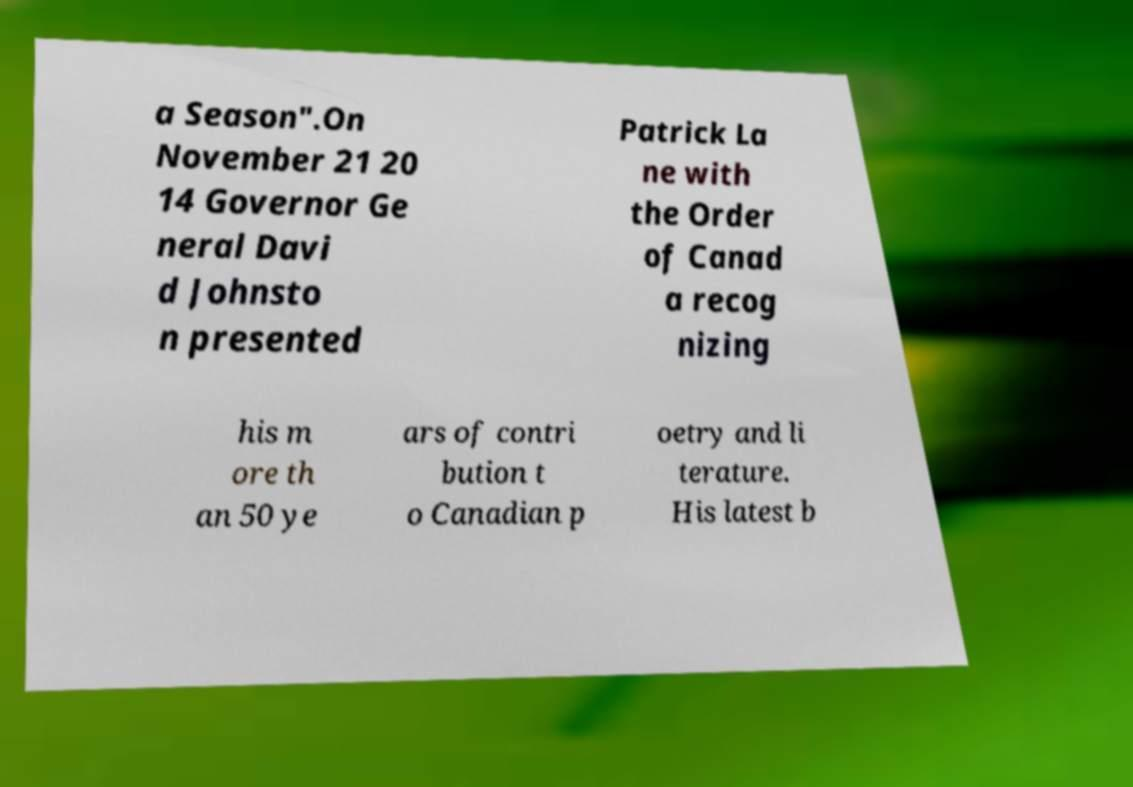There's text embedded in this image that I need extracted. Can you transcribe it verbatim? a Season".On November 21 20 14 Governor Ge neral Davi d Johnsto n presented Patrick La ne with the Order of Canad a recog nizing his m ore th an 50 ye ars of contri bution t o Canadian p oetry and li terature. His latest b 